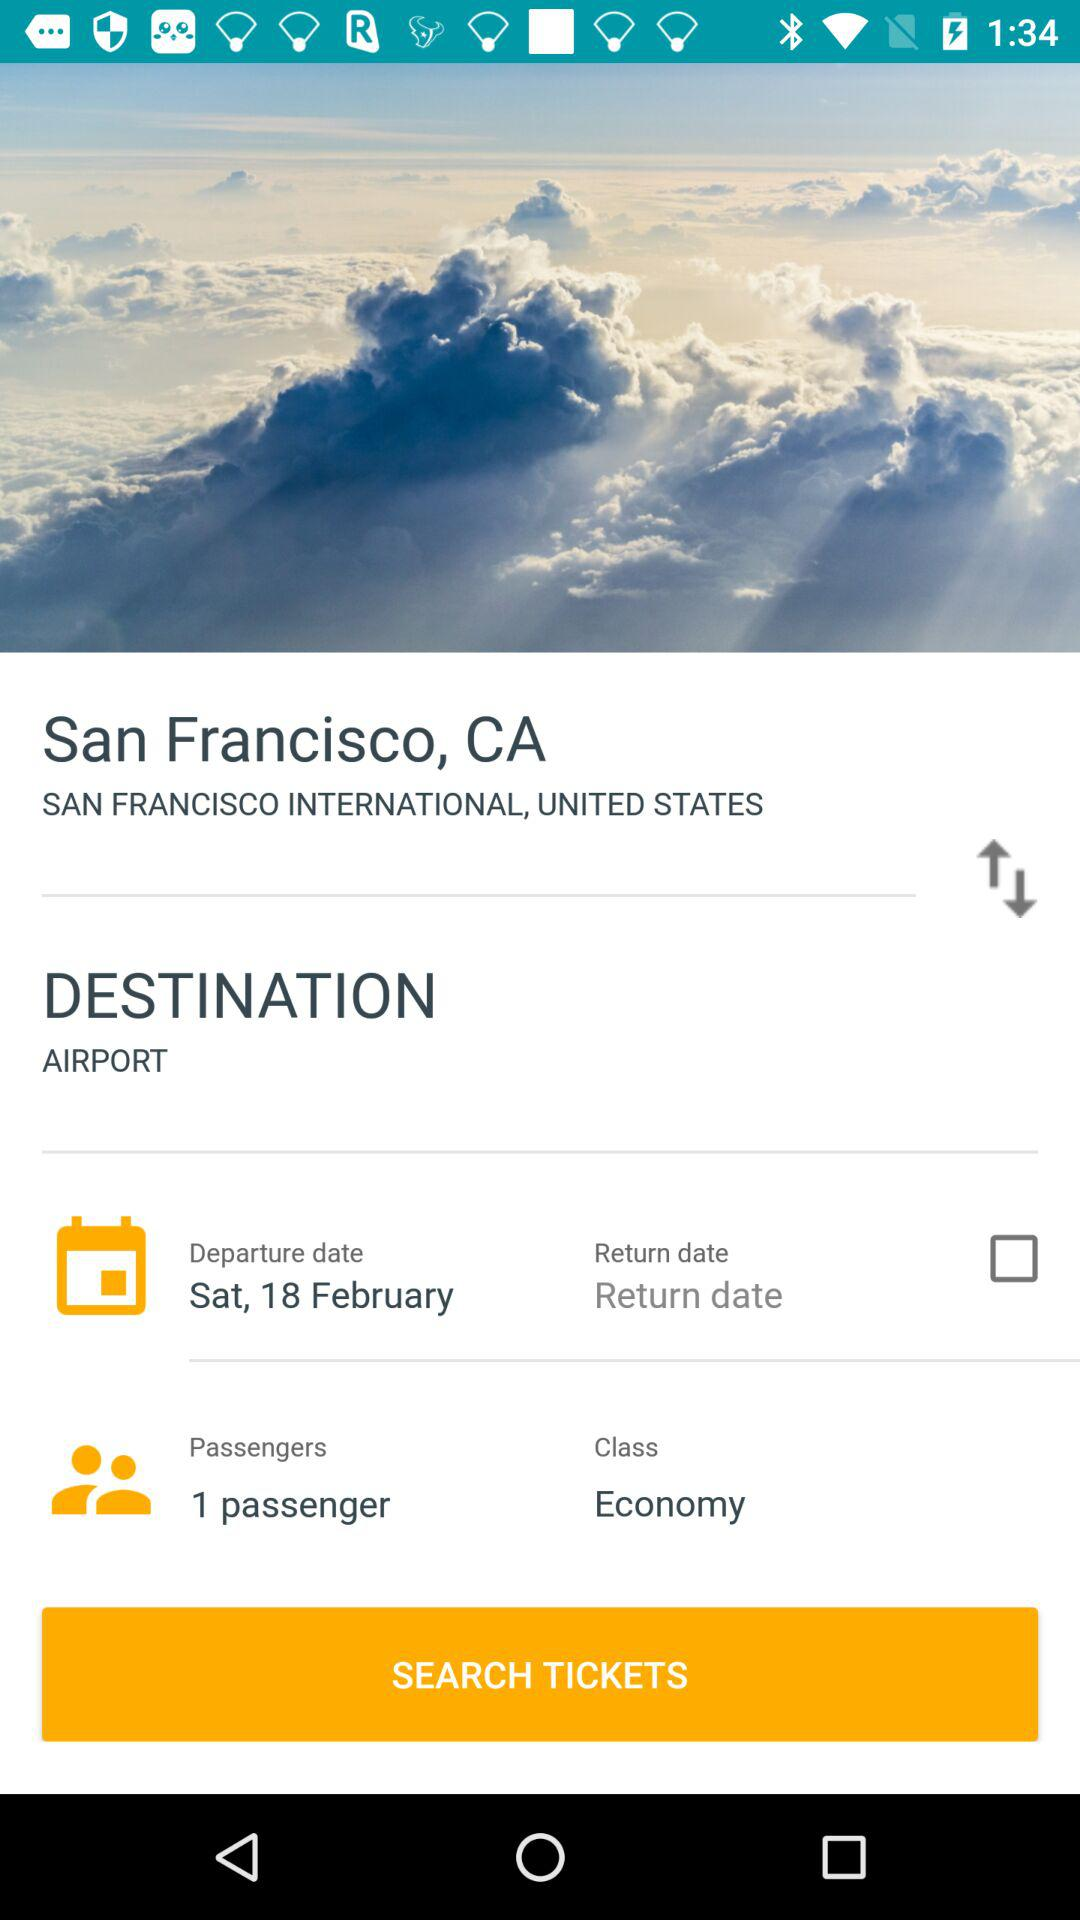How many passengers are being searched for tickets?
Answer the question using a single word or phrase. 1 